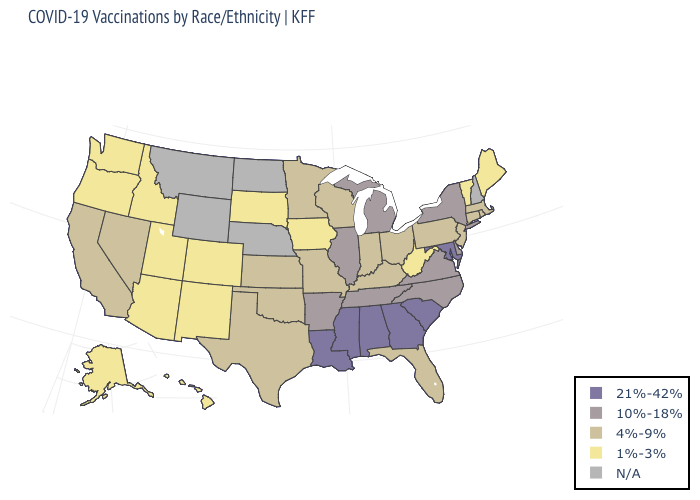Name the states that have a value in the range N/A?
Be succinct. Montana, Nebraska, New Hampshire, North Dakota, Wyoming. What is the value of Colorado?
Be succinct. 1%-3%. What is the value of New Jersey?
Write a very short answer. 4%-9%. What is the lowest value in states that border Wyoming?
Short answer required. 1%-3%. What is the lowest value in the South?
Quick response, please. 1%-3%. Name the states that have a value in the range 1%-3%?
Quick response, please. Alaska, Arizona, Colorado, Hawaii, Idaho, Iowa, Maine, New Mexico, Oregon, South Dakota, Utah, Vermont, Washington, West Virginia. Name the states that have a value in the range 21%-42%?
Write a very short answer. Alabama, Georgia, Louisiana, Maryland, Mississippi, South Carolina. Which states have the lowest value in the West?
Concise answer only. Alaska, Arizona, Colorado, Hawaii, Idaho, New Mexico, Oregon, Utah, Washington. What is the value of Michigan?
Write a very short answer. 10%-18%. What is the value of Arkansas?
Concise answer only. 10%-18%. Which states have the lowest value in the USA?
Quick response, please. Alaska, Arizona, Colorado, Hawaii, Idaho, Iowa, Maine, New Mexico, Oregon, South Dakota, Utah, Vermont, Washington, West Virginia. Name the states that have a value in the range 21%-42%?
Answer briefly. Alabama, Georgia, Louisiana, Maryland, Mississippi, South Carolina. What is the lowest value in the USA?
Concise answer only. 1%-3%. Name the states that have a value in the range 10%-18%?
Be succinct. Arkansas, Delaware, Illinois, Michigan, New York, North Carolina, Tennessee, Virginia. What is the value of South Carolina?
Quick response, please. 21%-42%. 